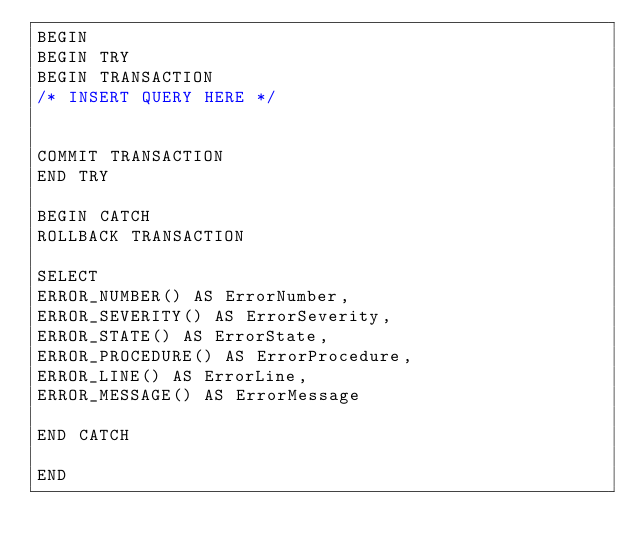<code> <loc_0><loc_0><loc_500><loc_500><_SQL_>BEGIN
BEGIN TRY
BEGIN TRANSACTION
/* INSERT QUERY HERE */


COMMIT TRANSACTION
END TRY

BEGIN CATCH
ROLLBACK TRANSACTION

SELECT
ERROR_NUMBER() AS ErrorNumber,
ERROR_SEVERITY() AS ErrorSeverity,
ERROR_STATE() AS ErrorState,
ERROR_PROCEDURE() AS ErrorProcedure,
ERROR_LINE() AS ErrorLine,
ERROR_MESSAGE() AS ErrorMessage

END CATCH

END</code> 